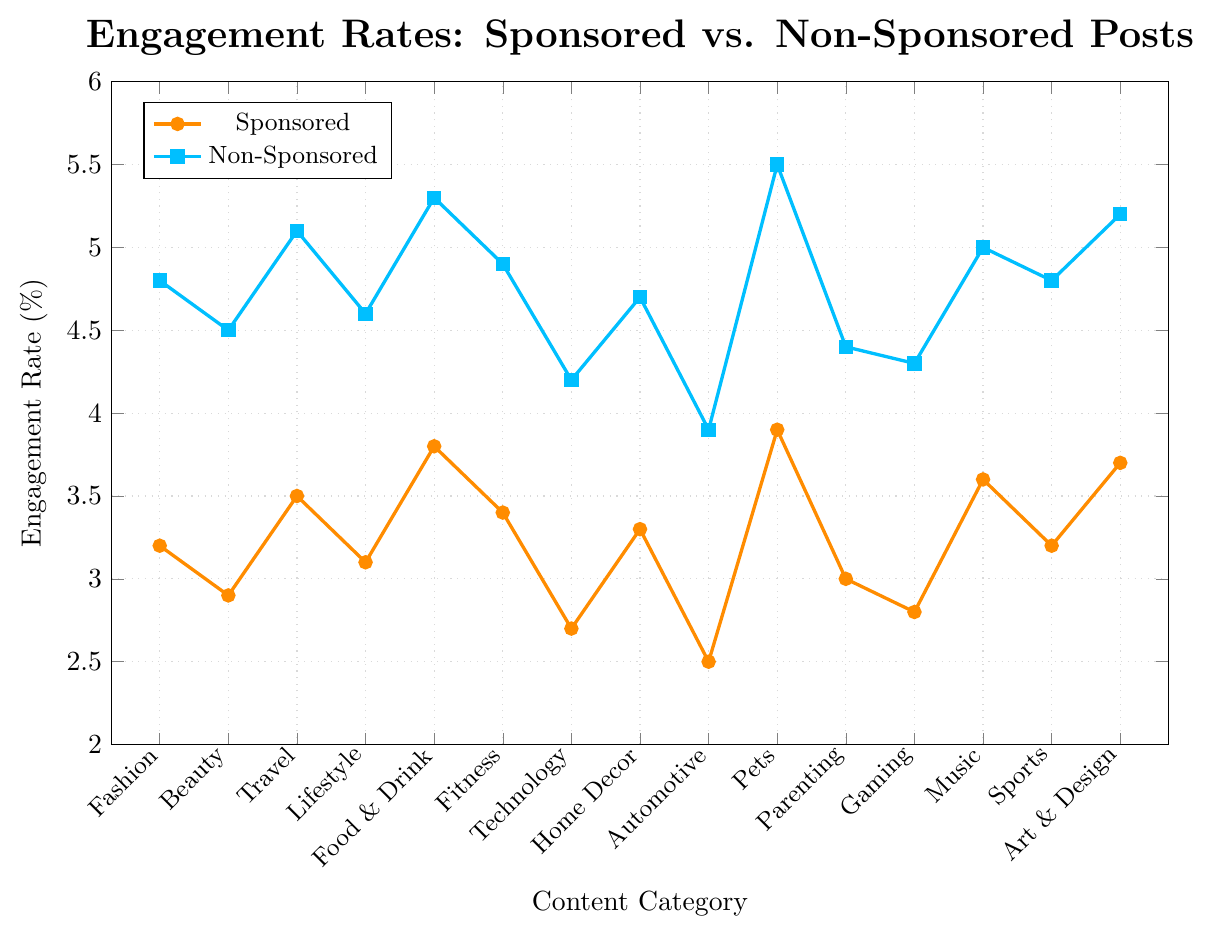What's the engagement rate for sponsored posts in the "Pets" category? Locate the "Pets" category on the x-axis and follow the data point upward to the sponsored engagement rate line, marked with a circular marker, which reads 3.9%.
Answer: 3.9% Which content category has the highest engagement rate for non-sponsored posts? Identify the highest point on the non-sponsored engagement line (square markers) and find the corresponding category on the x-axis, which is "Pets".
Answer: Pets What is the difference in engagement rates between sponsored and non-sponsored posts for the "Food & Drink" category? Check the engagement rates for "Food & Drink" category: Sponsored is 3.8% and Non-Sponsored is 5.3%. Subtract Sponsored engagement rate from Non-Sponsored engagement rate: 5.3% - 3.8% = 1.5%.
Answer: 1.5% Which has a higher engagement rate for sponsored posts, "Technology" or "Gaming"? Compare the engagement rates for sponsored posts in "Technology" (2.7%) and "Gaming" (2.8%). "Gaming" has a higher engagement rate.
Answer: Gaming What is the average engagement rate for sponsored posts across all categories? Sum the engagement rates for all categories for sponsored posts: (3.2 + 2.9 + 3.5 + 3.1 + 3.8 + 3.4 + 2.7 + 3.3 + 2.5 + 3.9 + 3.0 + 2.8 + 3.6 + 3.2 + 3.7) = 48.6%. Divide by the number of categories (15): 48.6 / 15 = 3.24%.
Answer: 3.24% For which content categories is the engagement rate difference between sponsored and non-sponsored posts the smallest? Calculate the differences for each category and compare them: "Automotive" has the smallest difference (3.9% - 2.5% = 1.4%).
Answer: Automotive Is the engagement rate for non-sponsored posts always higher than that for sponsored posts across all categories? Compare the engagement rates for all categories and note that the engagement rate for non-sponsored posts is higher than for sponsored posts in every category.
Answer: Yes Which content category has the lowest engagement rate for sponsored posts? Identify the lowest point on the sponsored engagement rate line (circular markers) and find the corresponding category, which is "Automotive".
Answer: Automotive What's the engagement rate improvement for "Travel" when switching from sponsored to non-sponsored posts? Check "Travel" category: Sponsored is 3.5%, Non-Sponsored is 5.1%. Calculate the improvement: 5.1% - 3.5% = 1.6%.
Answer: 1.6% How does the engagement rate for sponsored "Music" posts compare to non-sponsored "Fashion" posts? Engagement rate for "Music" sponsored posts is 3.6% and for "Fashion" non-sponsored posts is 4.8%. Compare the two values.
Answer: Non-Sponsored Fashion is higher 